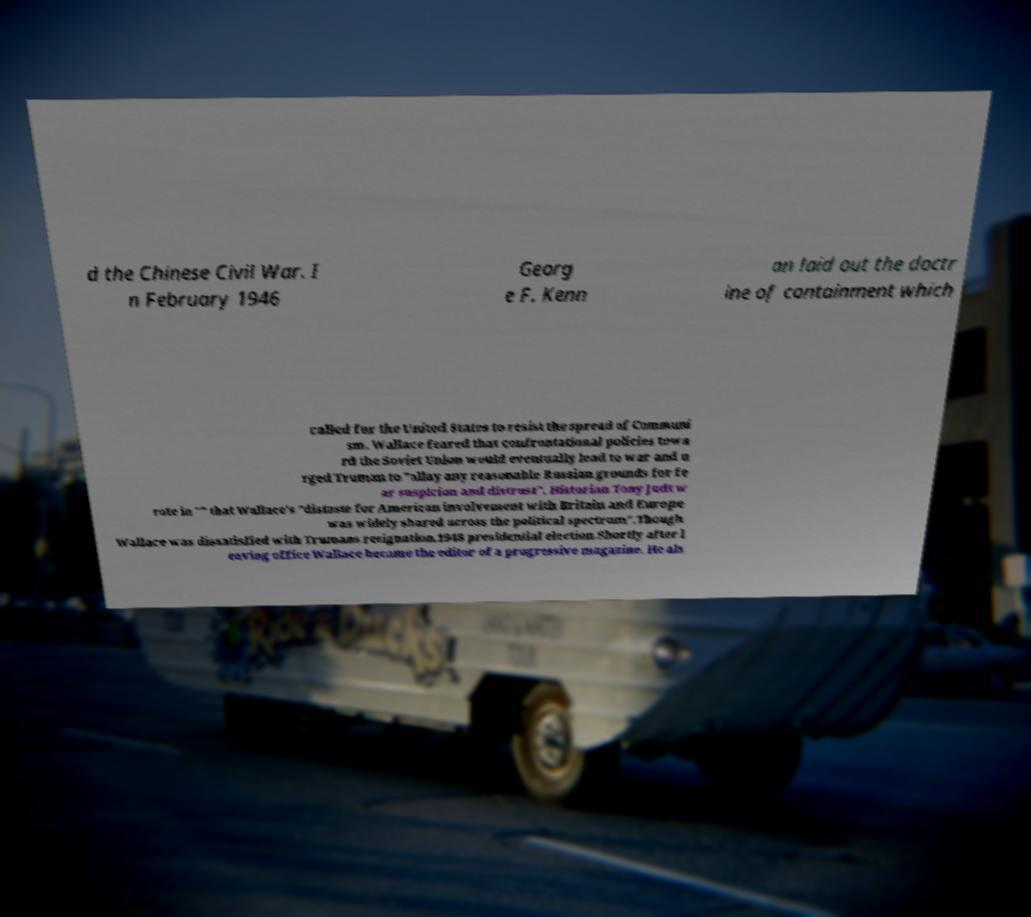Could you extract and type out the text from this image? d the Chinese Civil War. I n February 1946 Georg e F. Kenn an laid out the doctr ine of containment which called for the United States to resist the spread of Communi sm. Wallace feared that confrontational policies towa rd the Soviet Union would eventually lead to war and u rged Truman to "allay any reasonable Russian grounds for fe ar suspicion and distrust". Historian Tony Judt w rote in "" that Wallace's "distaste for American involvement with Britain and Europe was widely shared across the political spectrum".Though Wallace was dissatisfied with Trumans resignation.1948 presidential election.Shortly after l eaving office Wallace became the editor of a progressive magazine. He als 